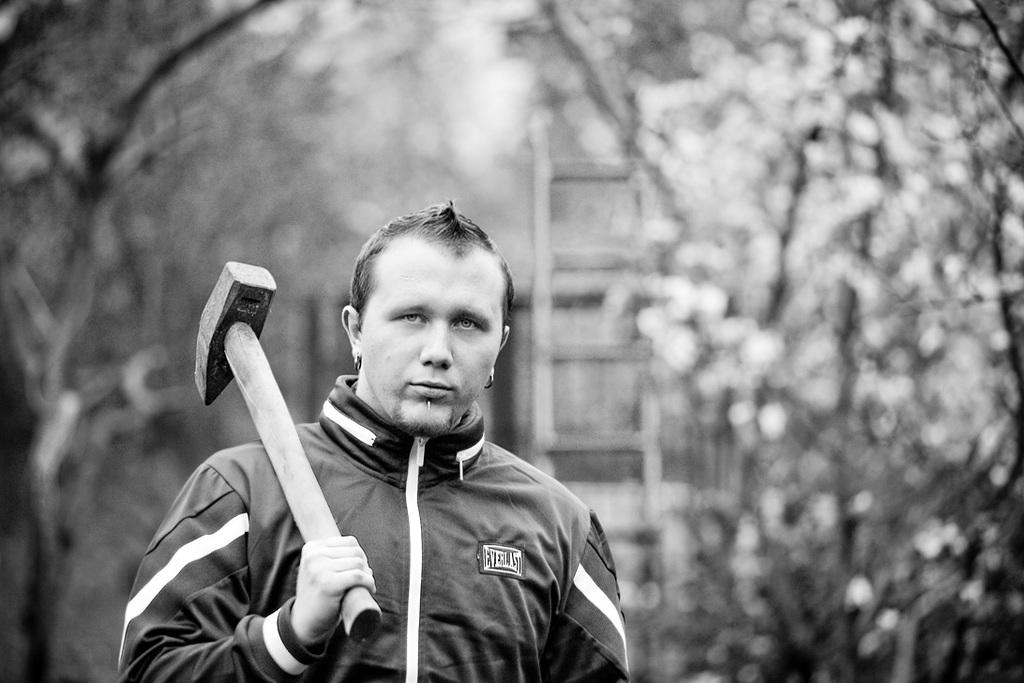What is the color scheme of the image? The image is black and white. Who is present in the image? There is a man in the image. What is the man holding in the image? The man is holding a hammer. What can be seen behind the man in the image? There are blurred objects behind the man. What type of cup can be seen on the hospital bed in the image? There is no cup or hospital bed present in the image. What kind of marble is visible on the floor in the image? There is no marble visible on the floor in the image. 